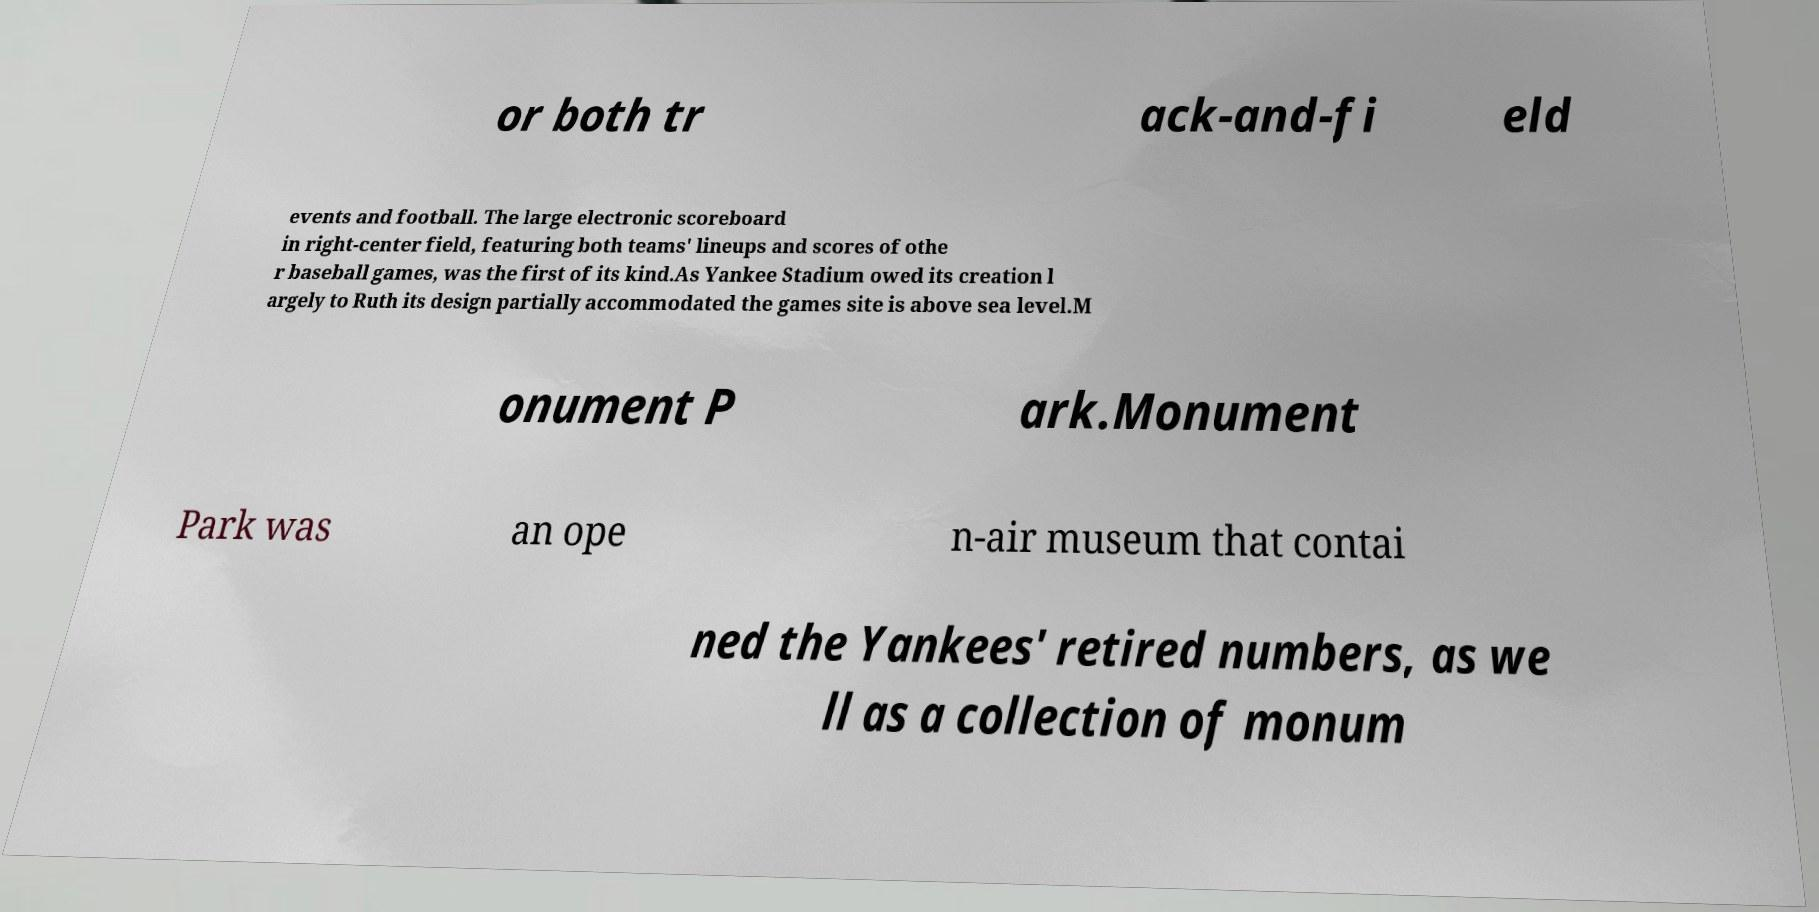Can you accurately transcribe the text from the provided image for me? or both tr ack-and-fi eld events and football. The large electronic scoreboard in right-center field, featuring both teams' lineups and scores of othe r baseball games, was the first of its kind.As Yankee Stadium owed its creation l argely to Ruth its design partially accommodated the games site is above sea level.M onument P ark.Monument Park was an ope n-air museum that contai ned the Yankees' retired numbers, as we ll as a collection of monum 